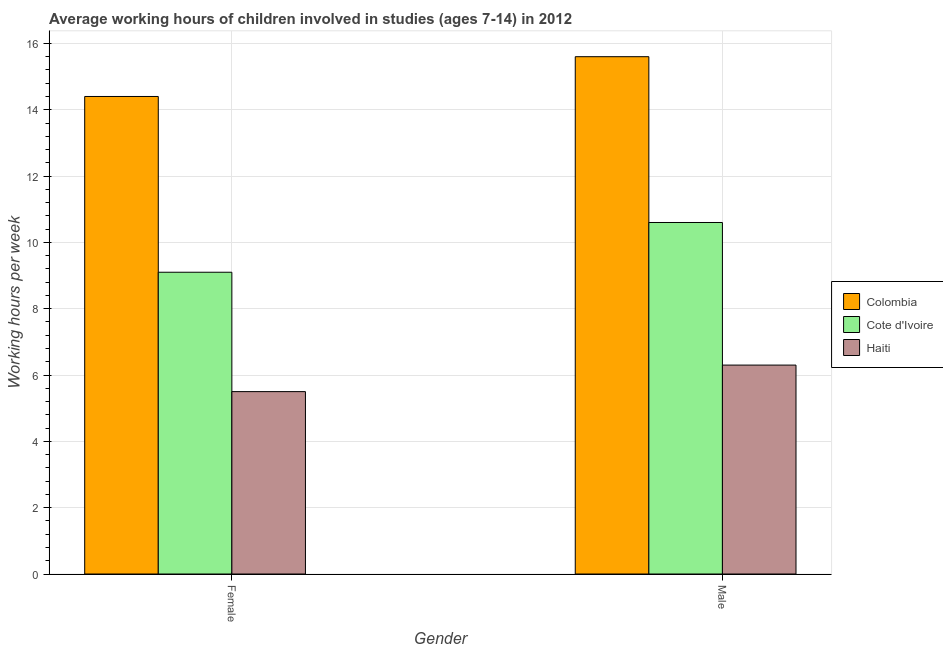How many bars are there on the 2nd tick from the left?
Your response must be concise. 3. How many bars are there on the 1st tick from the right?
Provide a short and direct response. 3. What is the label of the 2nd group of bars from the left?
Offer a terse response. Male. What is the average working hour of female children in Colombia?
Ensure brevity in your answer.  14.4. Across all countries, what is the minimum average working hour of female children?
Offer a very short reply. 5.5. In which country was the average working hour of male children minimum?
Make the answer very short. Haiti. What is the difference between the average working hour of male children in Colombia and the average working hour of female children in Haiti?
Your response must be concise. 10.1. What is the average average working hour of female children per country?
Your answer should be very brief. 9.67. What is the difference between the average working hour of male children and average working hour of female children in Haiti?
Keep it short and to the point. 0.8. In how many countries, is the average working hour of female children greater than 2 hours?
Give a very brief answer. 3. What is the ratio of the average working hour of female children in Haiti to that in Colombia?
Provide a succinct answer. 0.38. Is the average working hour of female children in Colombia less than that in Cote d'Ivoire?
Offer a terse response. No. What does the 2nd bar from the left in Female represents?
Give a very brief answer. Cote d'Ivoire. What does the 3rd bar from the right in Male represents?
Offer a terse response. Colombia. Are all the bars in the graph horizontal?
Your answer should be compact. No. What is the difference between two consecutive major ticks on the Y-axis?
Provide a short and direct response. 2. Are the values on the major ticks of Y-axis written in scientific E-notation?
Your answer should be very brief. No. Does the graph contain any zero values?
Your answer should be compact. No. Does the graph contain grids?
Keep it short and to the point. Yes. Where does the legend appear in the graph?
Make the answer very short. Center right. How many legend labels are there?
Offer a terse response. 3. How are the legend labels stacked?
Your response must be concise. Vertical. What is the title of the graph?
Ensure brevity in your answer.  Average working hours of children involved in studies (ages 7-14) in 2012. Does "Bangladesh" appear as one of the legend labels in the graph?
Provide a short and direct response. No. What is the label or title of the Y-axis?
Ensure brevity in your answer.  Working hours per week. What is the Working hours per week in Haiti in Female?
Your answer should be compact. 5.5. What is the Working hours per week in Colombia in Male?
Keep it short and to the point. 15.6. Across all Gender, what is the maximum Working hours per week in Colombia?
Make the answer very short. 15.6. Across all Gender, what is the maximum Working hours per week of Haiti?
Keep it short and to the point. 6.3. Across all Gender, what is the minimum Working hours per week in Colombia?
Give a very brief answer. 14.4. What is the total Working hours per week in Colombia in the graph?
Offer a terse response. 30. What is the total Working hours per week in Haiti in the graph?
Provide a short and direct response. 11.8. What is the difference between the Working hours per week of Colombia in Female and that in Male?
Offer a terse response. -1.2. What is the difference between the Working hours per week of Cote d'Ivoire in Female and that in Male?
Offer a very short reply. -1.5. What is the difference between the Working hours per week of Haiti in Female and that in Male?
Keep it short and to the point. -0.8. What is the difference between the Working hours per week in Colombia in Female and the Working hours per week in Haiti in Male?
Offer a very short reply. 8.1. What is the difference between the Working hours per week in Cote d'Ivoire in Female and the Working hours per week in Haiti in Male?
Your answer should be very brief. 2.8. What is the average Working hours per week in Cote d'Ivoire per Gender?
Provide a short and direct response. 9.85. What is the difference between the Working hours per week of Colombia and Working hours per week of Cote d'Ivoire in Female?
Your response must be concise. 5.3. What is the difference between the Working hours per week of Colombia and Working hours per week of Haiti in Male?
Offer a very short reply. 9.3. What is the difference between the Working hours per week of Cote d'Ivoire and Working hours per week of Haiti in Male?
Offer a very short reply. 4.3. What is the ratio of the Working hours per week of Cote d'Ivoire in Female to that in Male?
Provide a short and direct response. 0.86. What is the ratio of the Working hours per week of Haiti in Female to that in Male?
Provide a succinct answer. 0.87. What is the difference between the highest and the second highest Working hours per week in Colombia?
Give a very brief answer. 1.2. What is the difference between the highest and the second highest Working hours per week in Cote d'Ivoire?
Your answer should be compact. 1.5. What is the difference between the highest and the lowest Working hours per week of Cote d'Ivoire?
Provide a short and direct response. 1.5. What is the difference between the highest and the lowest Working hours per week of Haiti?
Ensure brevity in your answer.  0.8. 